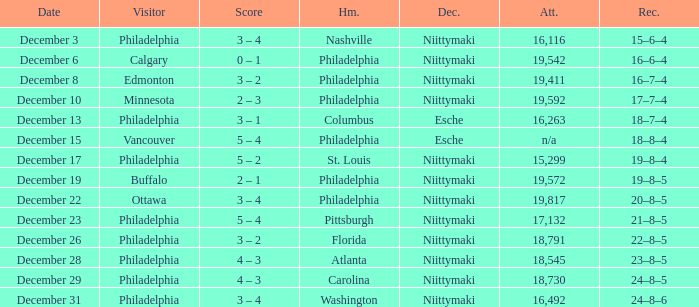What was the score when the attendance was 18,545? 4 – 3. 